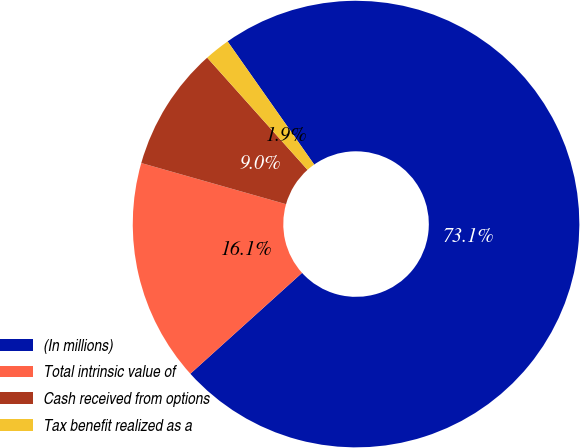Convert chart. <chart><loc_0><loc_0><loc_500><loc_500><pie_chart><fcel>(In millions)<fcel>Total intrinsic value of<fcel>Cash received from options<fcel>Tax benefit realized as a<nl><fcel>73.07%<fcel>16.1%<fcel>8.98%<fcel>1.86%<nl></chart> 